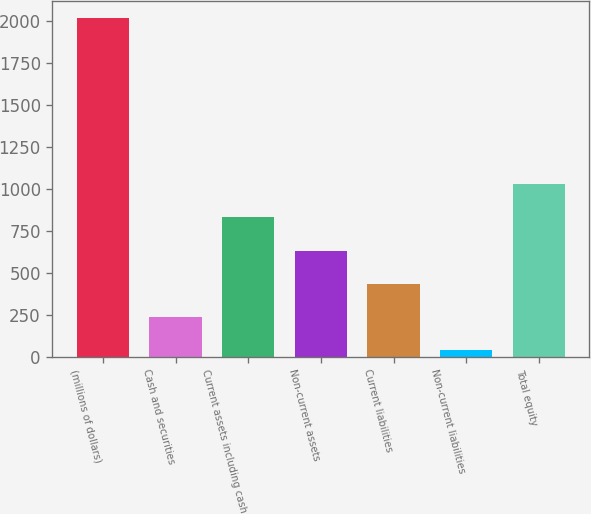<chart> <loc_0><loc_0><loc_500><loc_500><bar_chart><fcel>(millions of dollars)<fcel>Cash and securities<fcel>Current assets including cash<fcel>Non-current assets<fcel>Current liabilities<fcel>Non-current liabilities<fcel>Total equity<nl><fcel>2015<fcel>236.87<fcel>829.58<fcel>632.01<fcel>434.44<fcel>39.3<fcel>1027.15<nl></chart> 